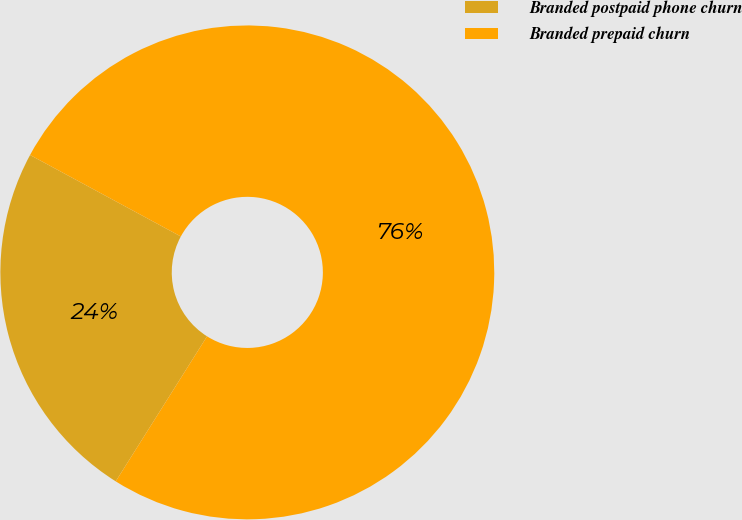<chart> <loc_0><loc_0><loc_500><loc_500><pie_chart><fcel>Branded postpaid phone churn<fcel>Branded prepaid churn<nl><fcel>23.94%<fcel>76.06%<nl></chart> 